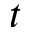Convert formula to latex. <formula><loc_0><loc_0><loc_500><loc_500>t</formula> 